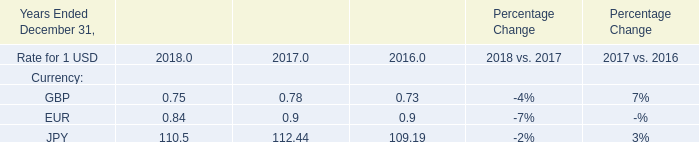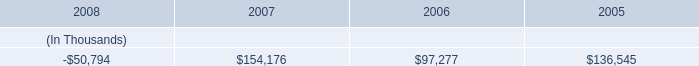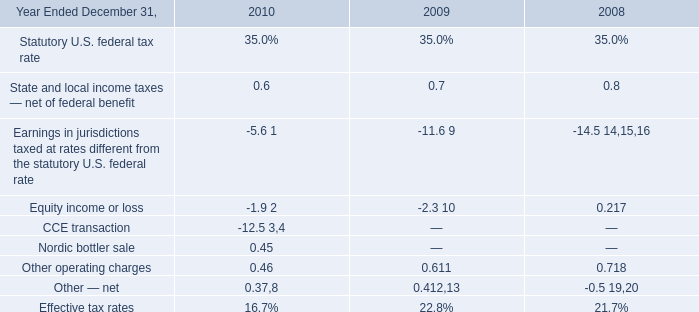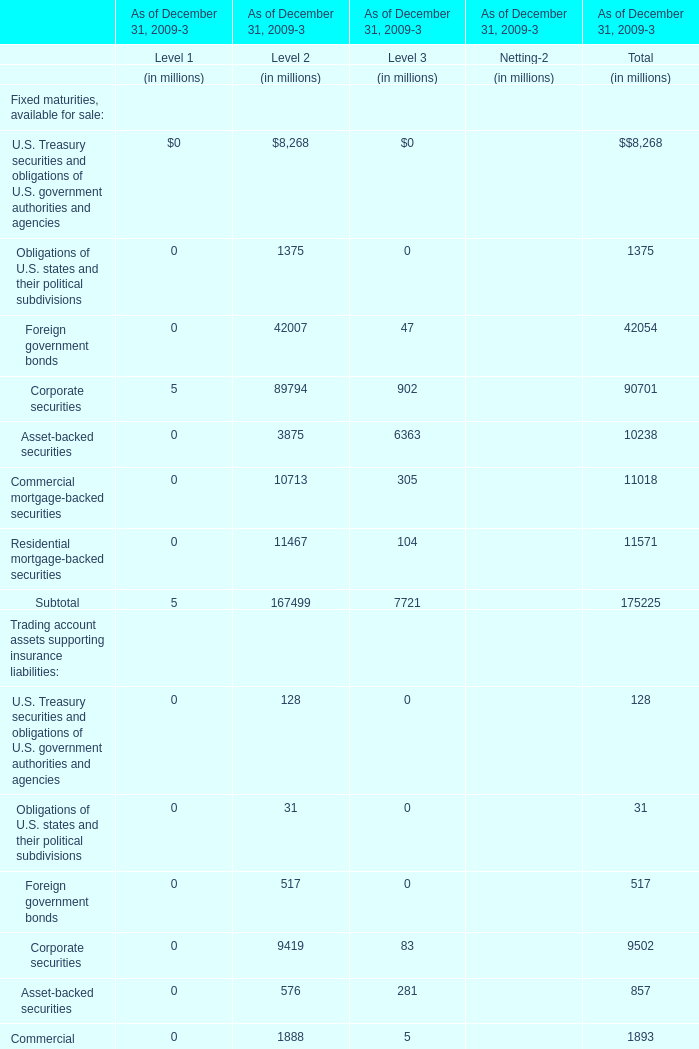Which Level is the Total assets as of December 31, 2009 the least? 
Answer: 3. 